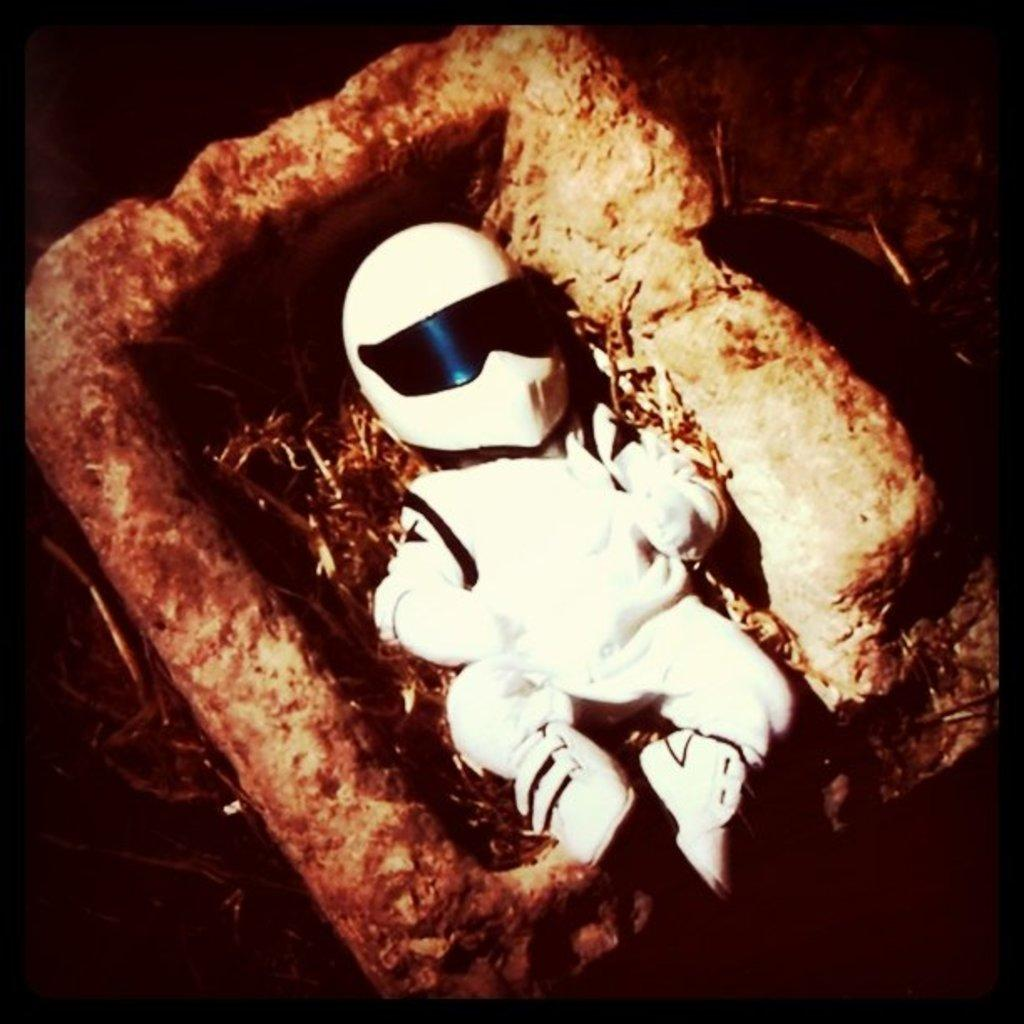What is the main subject in the foreground of the image? There is a toy in the foreground of the image. What is the toy placed in? The toy is in a mud rectangular object. What type of songs can be heard coming from the toy in the image? There is no indication in the image that the toy is making any sounds, let alone songs. 